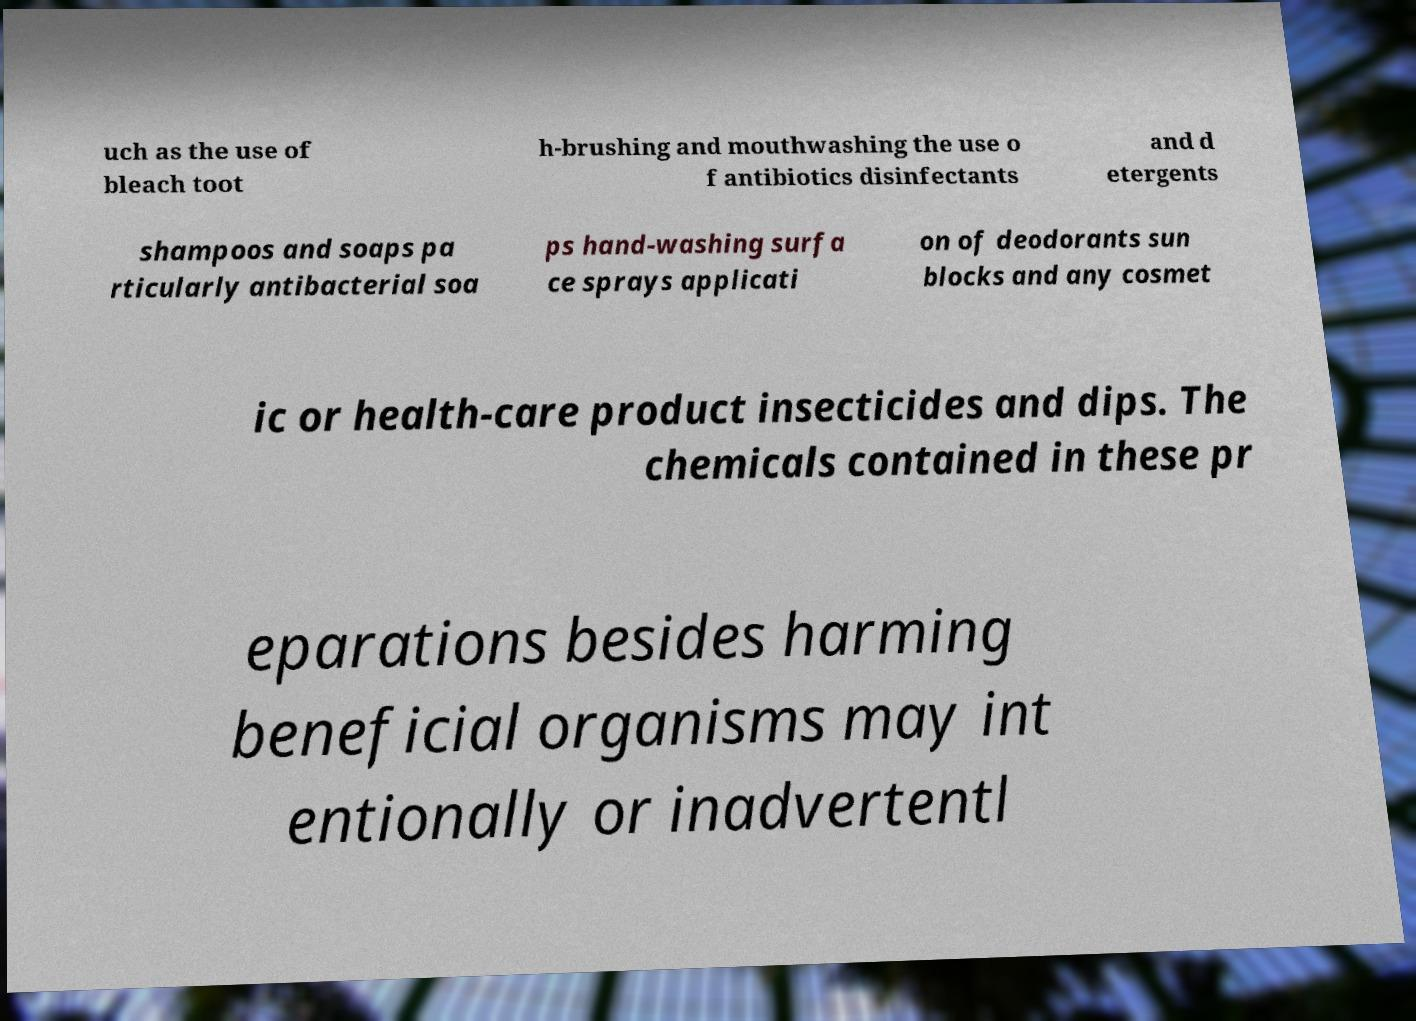Could you assist in decoding the text presented in this image and type it out clearly? uch as the use of bleach toot h-brushing and mouthwashing the use o f antibiotics disinfectants and d etergents shampoos and soaps pa rticularly antibacterial soa ps hand-washing surfa ce sprays applicati on of deodorants sun blocks and any cosmet ic or health-care product insecticides and dips. The chemicals contained in these pr eparations besides harming beneficial organisms may int entionally or inadvertentl 